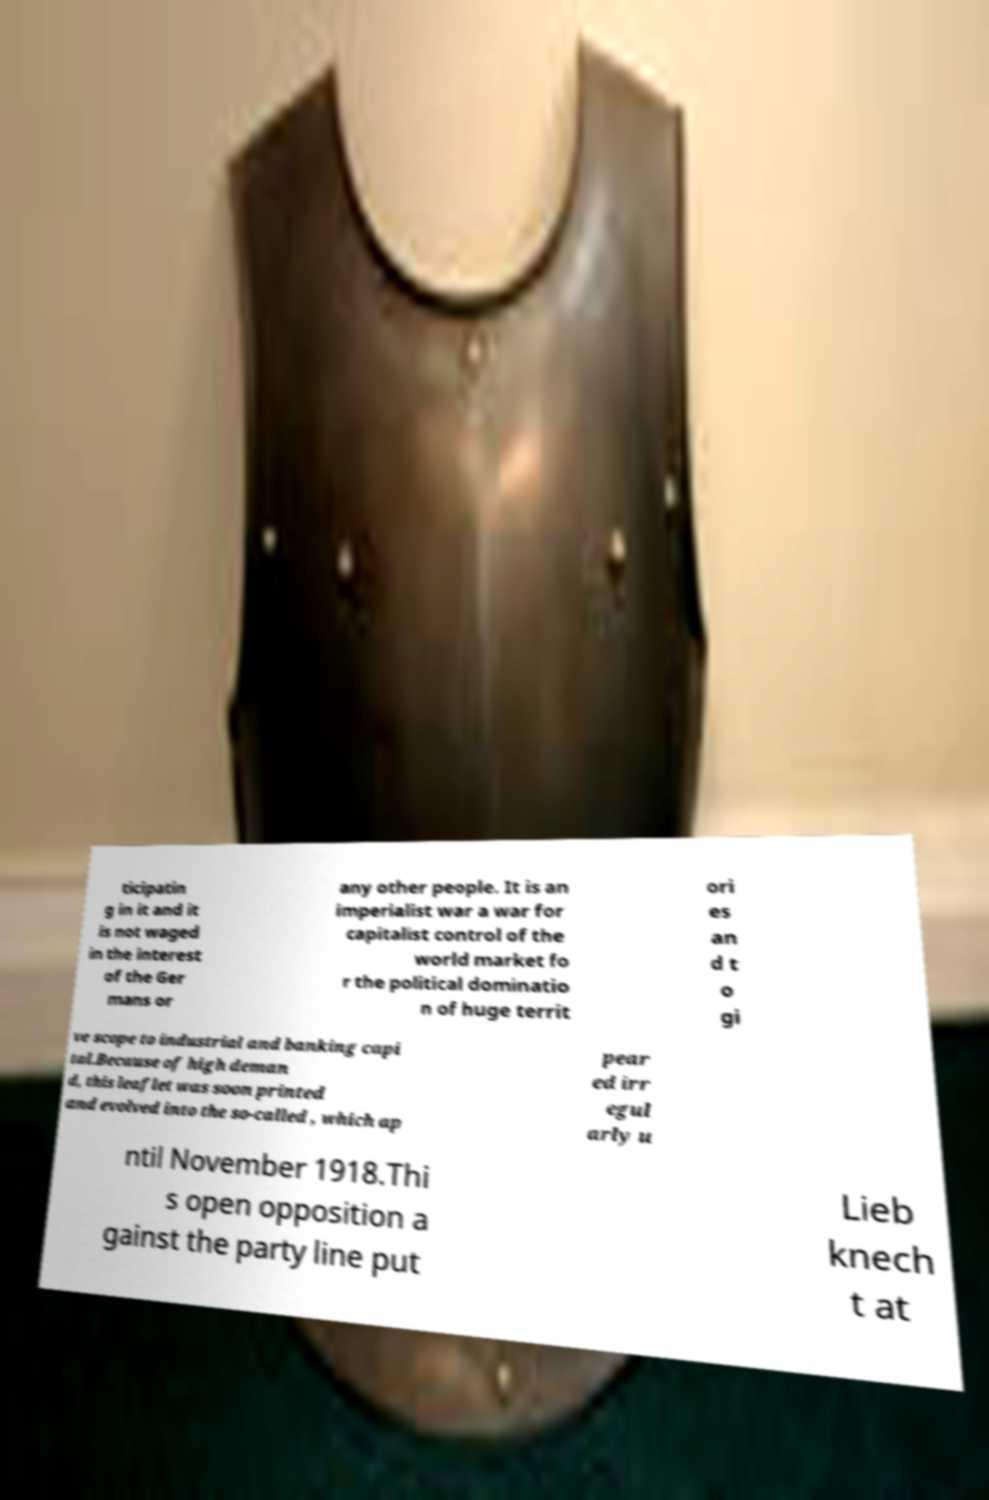What messages or text are displayed in this image? I need them in a readable, typed format. ticipatin g in it and it is not waged in the interest of the Ger mans or any other people. It is an imperialist war a war for capitalist control of the world market fo r the political dominatio n of huge territ ori es an d t o gi ve scope to industrial and banking capi tal.Because of high deman d, this leaflet was soon printed and evolved into the so-called , which ap pear ed irr egul arly u ntil November 1918.Thi s open opposition a gainst the party line put Lieb knech t at 